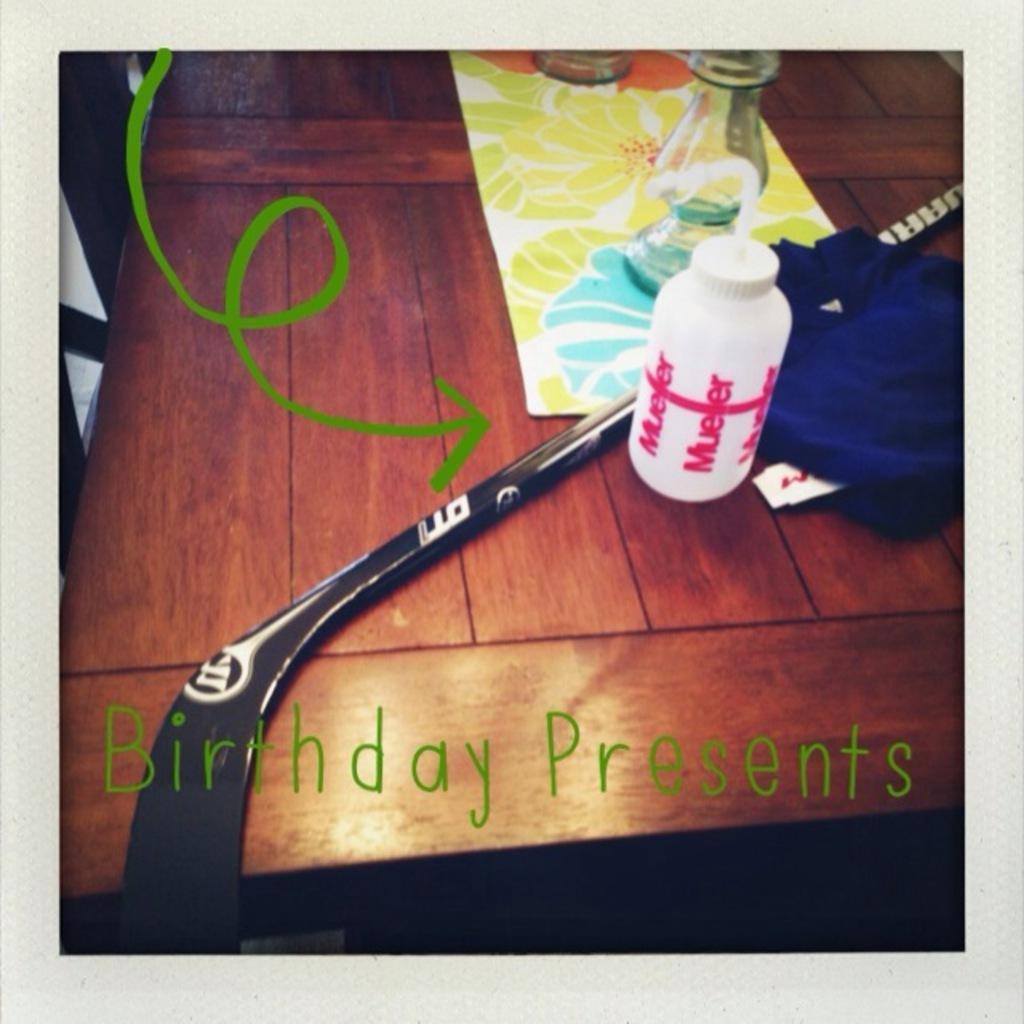Can you describe this image briefly? There is a table in the image. on that there is bottled, table mat, cloth,stick. On bottom it is written birthday presents. 